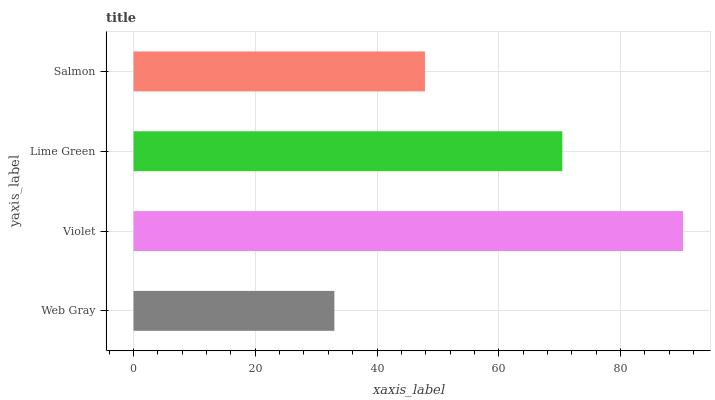Is Web Gray the minimum?
Answer yes or no. Yes. Is Violet the maximum?
Answer yes or no. Yes. Is Lime Green the minimum?
Answer yes or no. No. Is Lime Green the maximum?
Answer yes or no. No. Is Violet greater than Lime Green?
Answer yes or no. Yes. Is Lime Green less than Violet?
Answer yes or no. Yes. Is Lime Green greater than Violet?
Answer yes or no. No. Is Violet less than Lime Green?
Answer yes or no. No. Is Lime Green the high median?
Answer yes or no. Yes. Is Salmon the low median?
Answer yes or no. Yes. Is Web Gray the high median?
Answer yes or no. No. Is Violet the low median?
Answer yes or no. No. 